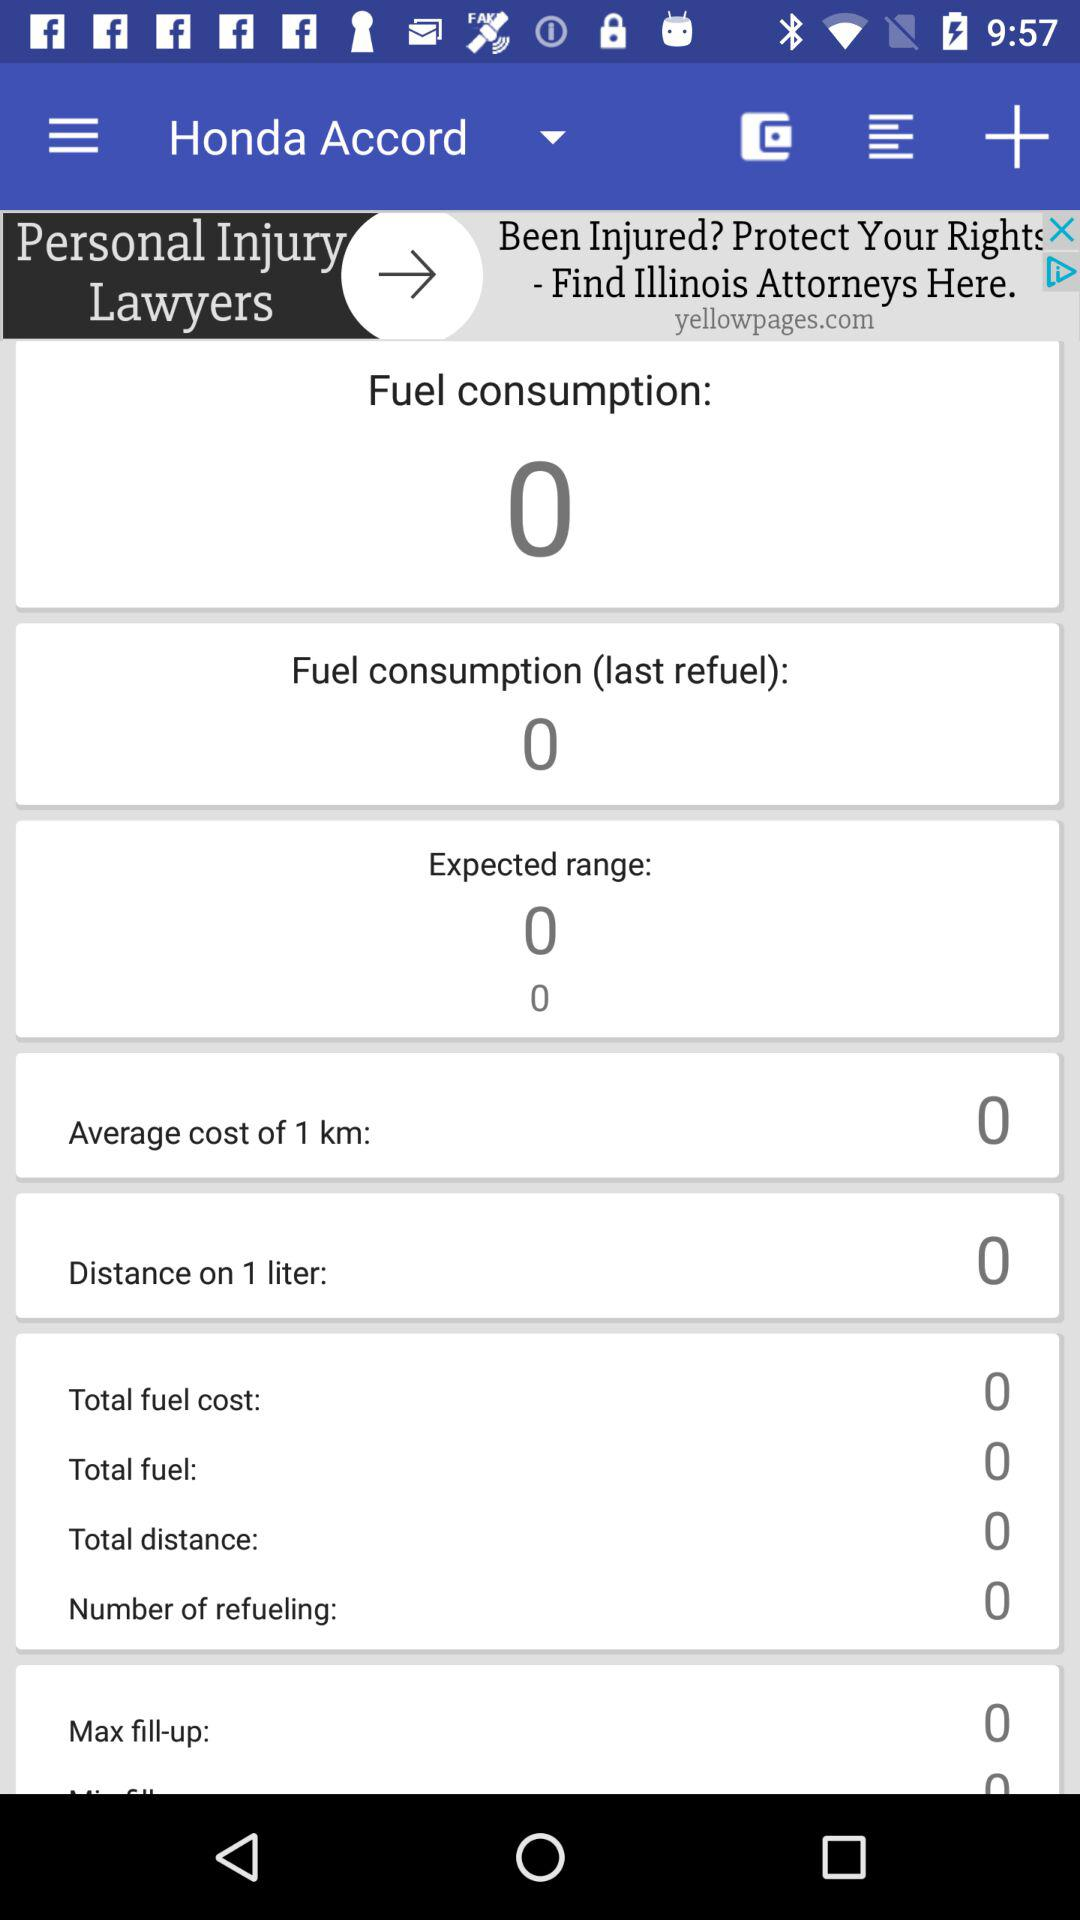How much is the fuel consumption? The fuel consumption is zero. 